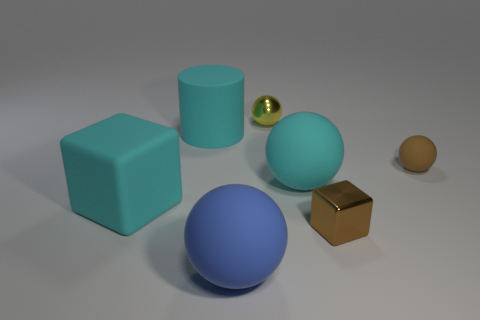Subtract all brown balls. How many balls are left? 3 Add 1 large cubes. How many objects exist? 8 Subtract 1 spheres. How many spheres are left? 3 Subtract all brown balls. How many balls are left? 3 Subtract all balls. How many objects are left? 3 Subtract all purple spheres. Subtract all red cylinders. How many spheres are left? 4 Subtract all yellow shiny spheres. Subtract all big blue spheres. How many objects are left? 5 Add 4 cyan objects. How many cyan objects are left? 7 Add 4 yellow rubber cylinders. How many yellow rubber cylinders exist? 4 Subtract 0 green cylinders. How many objects are left? 7 